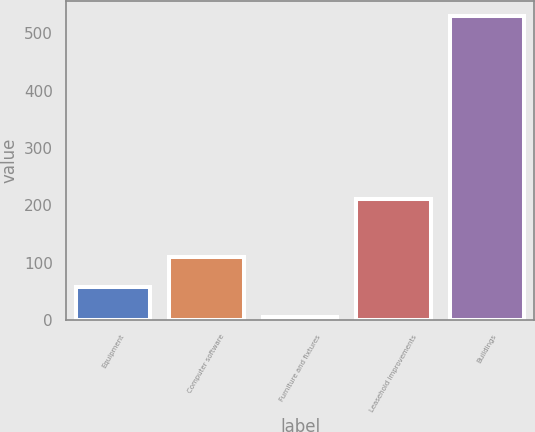Convert chart. <chart><loc_0><loc_0><loc_500><loc_500><bar_chart><fcel>Equipment<fcel>Computer software<fcel>Furniture and fixtures<fcel>Leasehold improvements<fcel>Buildings<nl><fcel>57.5<fcel>110<fcel>5<fcel>211<fcel>530<nl></chart> 